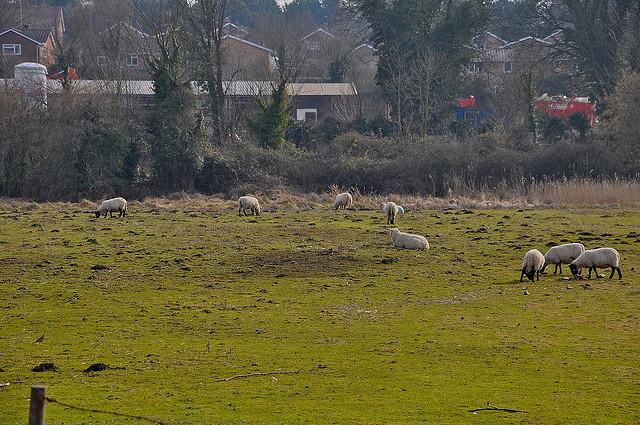What are the sheep doing?
Answer briefly. Grazing. Is it a sunny day?
Keep it brief. Yes. Was a filter used on this picture?
Quick response, please. No. How many sheep are in the back?
Write a very short answer. 8. What animals are these?
Keep it brief. Sheep. How many sheep are in the pasture?
Give a very brief answer. 8. What kind of animal is in the photo?
Be succinct. Sheep. Are the sheep shorn?
Short answer required. No. Is this farm in a rural area?
Write a very short answer. No. Is this a farm?
Quick response, please. Yes. How many sheep are there?
Short answer required. 8. 